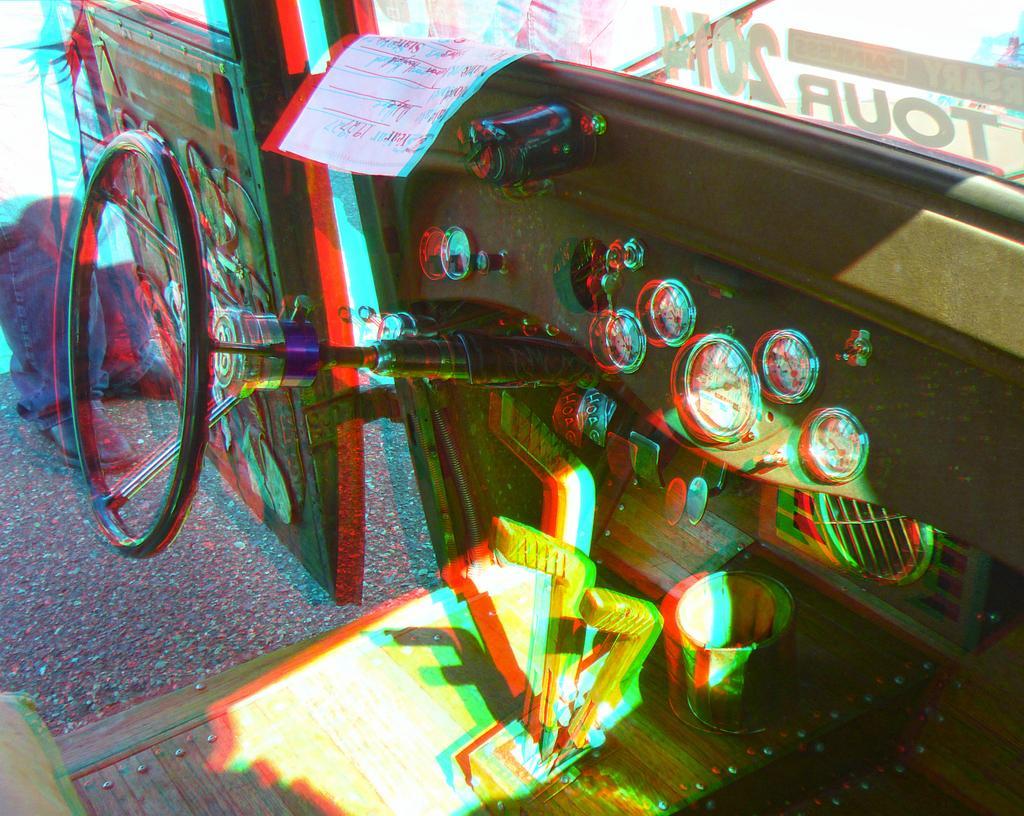Describe this image in one or two sentences. In this image we can see an inside of a vehicle. At the top we can see a paper and a glass. On the glass and paper we can see the text. On the left side, we can see the legs of a person. 